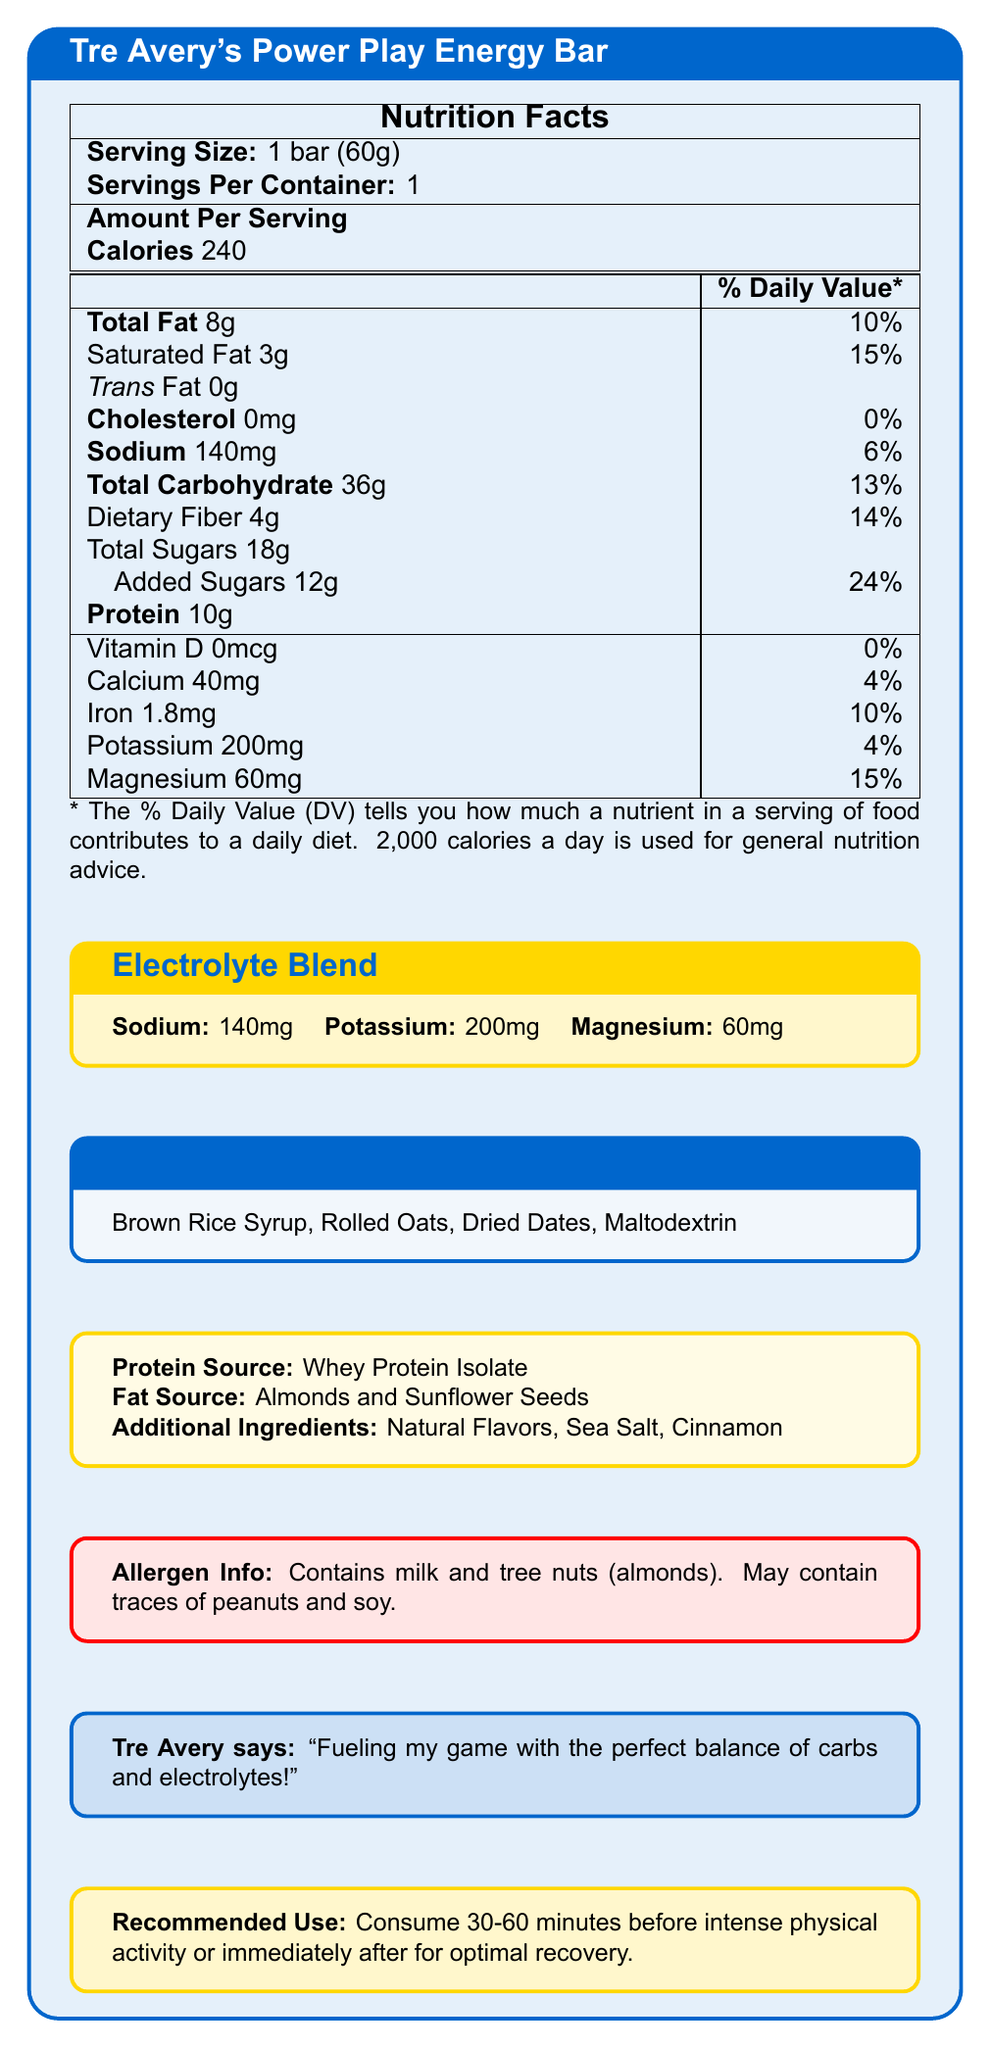what is the serving size? The serving size is explicitly mentioned in the document as 1 bar (60g).
Answer: 1 bar (60g) how many calories are in one serving? The document states that there are 240 calories per serving.
Answer: 240 what is the total amount of carbohydrates in the energy bar? The total carbohydrate amount is listed as 36g.
Answer: 36g how much sodium does the energy bar contain? The sodium content is listed as 140mg.
Answer: 140mg what is the percentage of daily value for magnesium? The document indicates that magnesium constitutes 15% of the daily value.
Answer: 15% what are the primary sources of protein in the energy bar? The document states that the protein source is Whey Protein Isolate.
Answer: Whey Protein Isolate what is the primary fat source in the energy bar? A. Coconut Oil B. Almonds and Sunflower Seeds C. Olive Oil D. Butter The document specifies that the fat sources are Almonds and Sunflower Seeds.
Answer: B which of the following is NOT listed as an ingredient in the carbohydrate blend? I. Brown Rice Syrup II. Rolled Oats III. Corn Syrup IV. Dried Dates The ingredients listed in the carbohydrate blend are Brown Rice Syrup, Rolled Oats, Dried Dates, and Maltodextrin. Corn Syrup is not included.
Answer: III does the energy bar contain any trans fat? The document states that the energy bar contains 0g of trans fat.
Answer: No is there any vitamin D present in the energy bar? The amount of vitamin D is listed as 0mcg, indicating there is no vitamin D present.
Answer: No summarize the main nutritional features of Tre Avery's Power Play Energy Bar. This summary reflects the main nutritional highlights provided in the document, focusing on calories, fats, carbohydrates, protein, and electrolytes.
Answer: The bar has 240 calories per serving, 8g of total fat, 36g of carbohydrates, and 10g of protein. It contains 140mg of sodium, 200mg of potassium, and 60mg of magnesium for electrolytes. The carbohydrate sources include Brown Rice Syrup, Rolled Oats, Dried Dates, and Maltodextrin. The bar also contains added sugars and provides a mix of essential nutrients for athletes. what is the exact percentage of the daily value for dietary fiber? The percentage of the daily value for dietary fiber is given as 14%.
Answer: 14% how much added sugar is included in the bar? The document indicates that there are 12g of added sugars in the bar.
Answer: 12g what is the recommended use for the energy bar according to Tre Avery? The document recommends consuming the bar 30-60 minutes before intense physical activity or immediately after for optimal recovery.
Answer: Consume 30-60 minutes before intense physical activity or immediately after for optimal recovery. which endorsement does Tre Avery give for this energy bar? The document features a quote from Tre Avery stating his endorsement.
Answer: "Fueling my game with the perfect balance of carbs and electrolytes!" are there any potential allergens listed? The document mentions that the bar contains milk and tree nuts (almonds) and may contain traces of peanuts and soy.
Answer: Yes how much calcium is in the energy bar? The calcium content is explicitly listed as 40mg.
Answer: 40mg what is the daily value percentage for iron in the bar? The document shows that the iron content is 10% of the daily value.
Answer: 10% what is the protein content per serving? A. 5g B. 7g C. 10g D. 15g The document states that the energy bar contains 10g of protein per serving.
Answer: C can I determine the manufacturing date from the document? The document does not provide any information regarding the manufacturing date.
Answer: Not enough information 